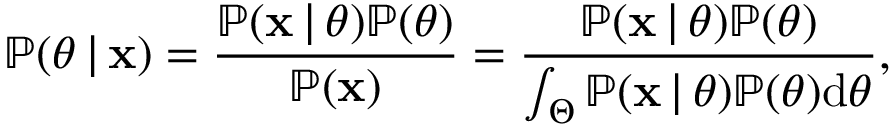<formula> <loc_0><loc_0><loc_500><loc_500>\mathbb { P } ( \theta \, | \, x ) = \frac { \mathbb { P } ( x \, | \, \theta ) \mathbb { P } ( \theta ) } { \mathbb { P } ( x ) } = \frac { \mathbb { P } ( x \, | \, \theta ) \mathbb { P } ( \theta ) } { \int _ { \Theta } \mathbb { P } ( x \, | \, \theta ) \mathbb { P } ( \theta ) d \theta } ,</formula> 